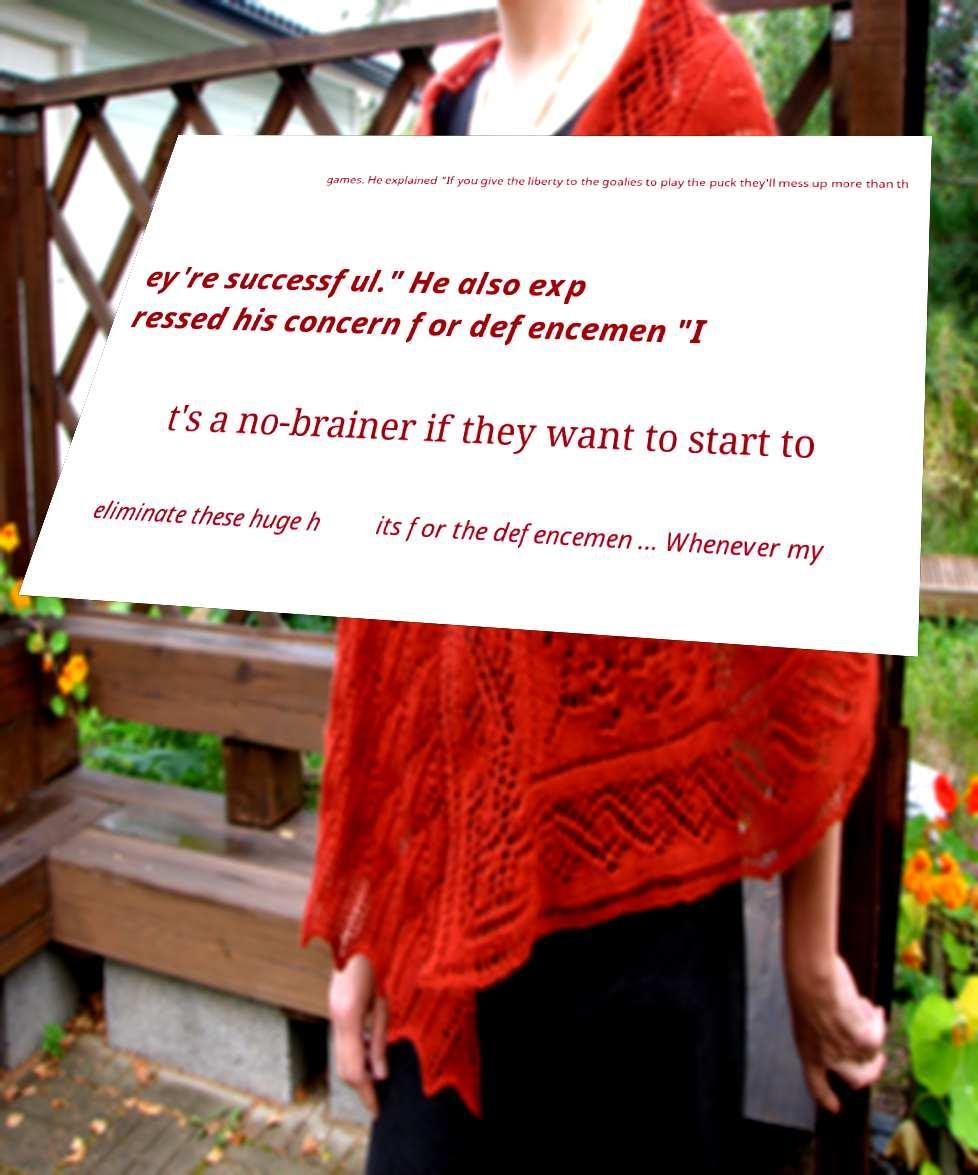Can you read and provide the text displayed in the image?This photo seems to have some interesting text. Can you extract and type it out for me? games. He explained "If you give the liberty to the goalies to play the puck they'll mess up more than th ey're successful." He also exp ressed his concern for defencemen "I t's a no-brainer if they want to start to eliminate these huge h its for the defencemen ... Whenever my 